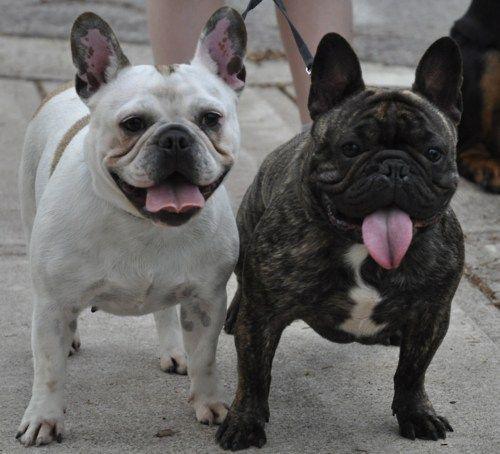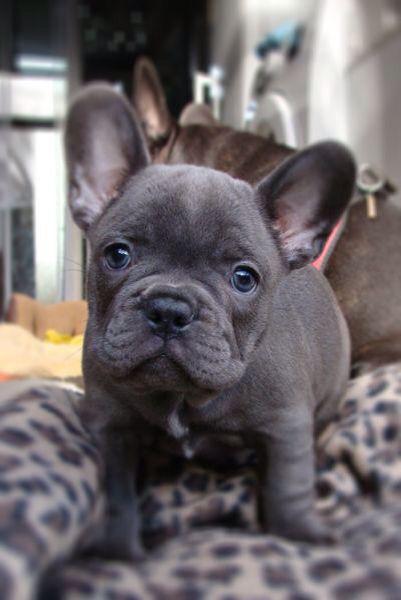The first image is the image on the left, the second image is the image on the right. Analyze the images presented: Is the assertion "The left image contains exactly two dogs." valid? Answer yes or no. Yes. The first image is the image on the left, the second image is the image on the right. Considering the images on both sides, is "There are two dogs in the left image." valid? Answer yes or no. Yes. 